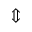Convert formula to latex. <formula><loc_0><loc_0><loc_500><loc_500>\Updownarrow</formula> 